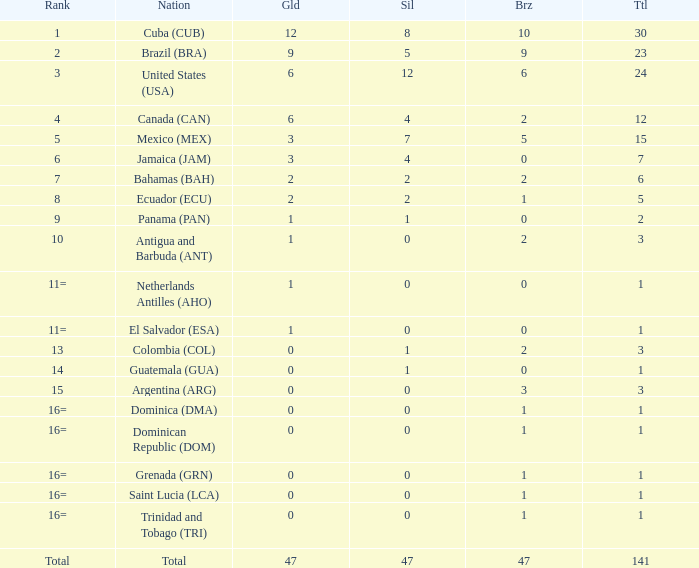How many bronzes have a Nation of jamaica (jam), and a Total smaller than 7? 0.0. 